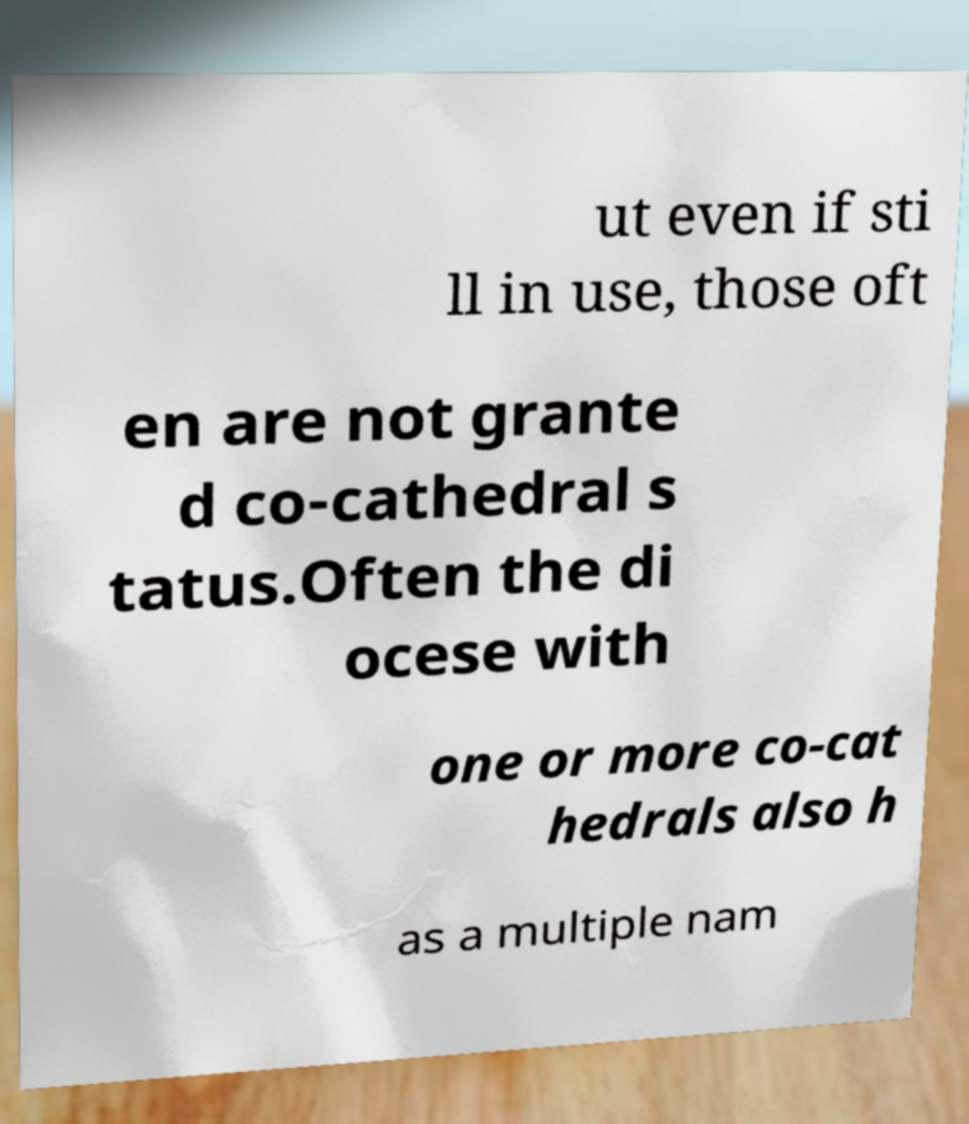For documentation purposes, I need the text within this image transcribed. Could you provide that? ut even if sti ll in use, those oft en are not grante d co-cathedral s tatus.Often the di ocese with one or more co-cat hedrals also h as a multiple nam 